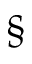<formula> <loc_0><loc_0><loc_500><loc_500>\S</formula> 